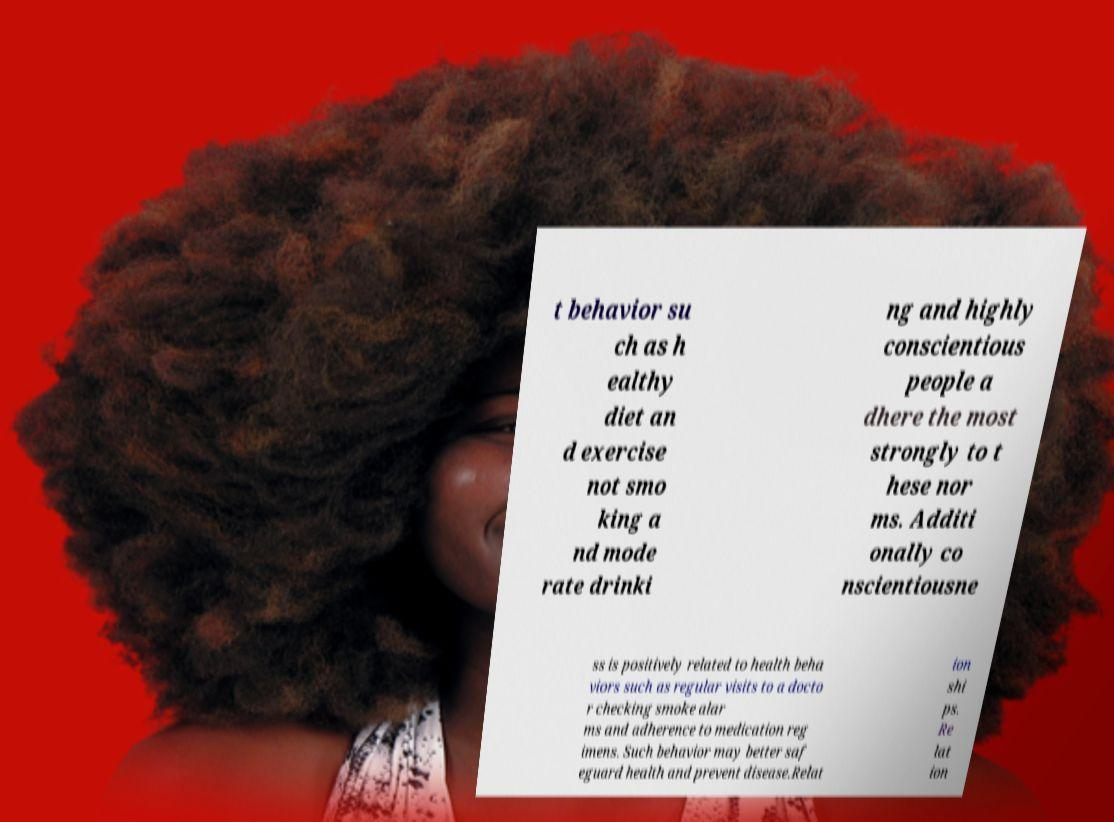Can you accurately transcribe the text from the provided image for me? t behavior su ch as h ealthy diet an d exercise not smo king a nd mode rate drinki ng and highly conscientious people a dhere the most strongly to t hese nor ms. Additi onally co nscientiousne ss is positively related to health beha viors such as regular visits to a docto r checking smoke alar ms and adherence to medication reg imens. Such behavior may better saf eguard health and prevent disease.Relat ion shi ps. Re lat ion 